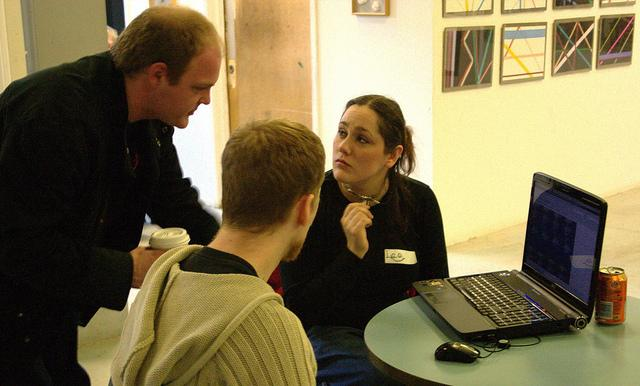What are the people assembled around?

Choices:
A) laptop
B) dinner table
C) barbecue grill
D) movie screen laptop 